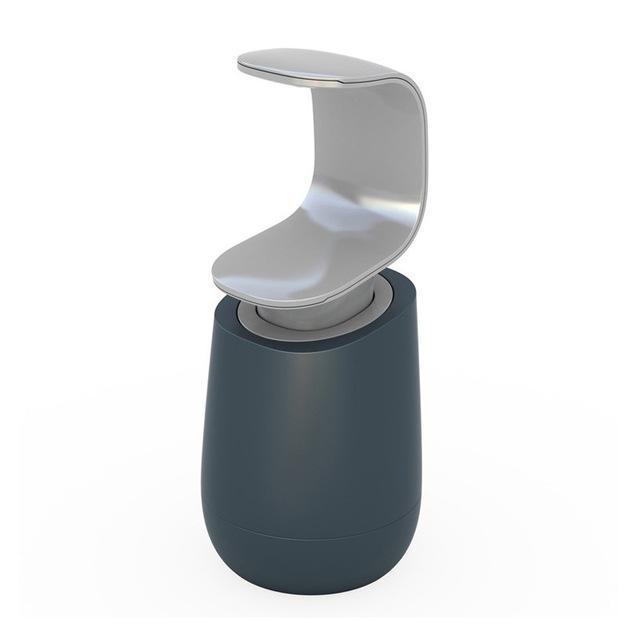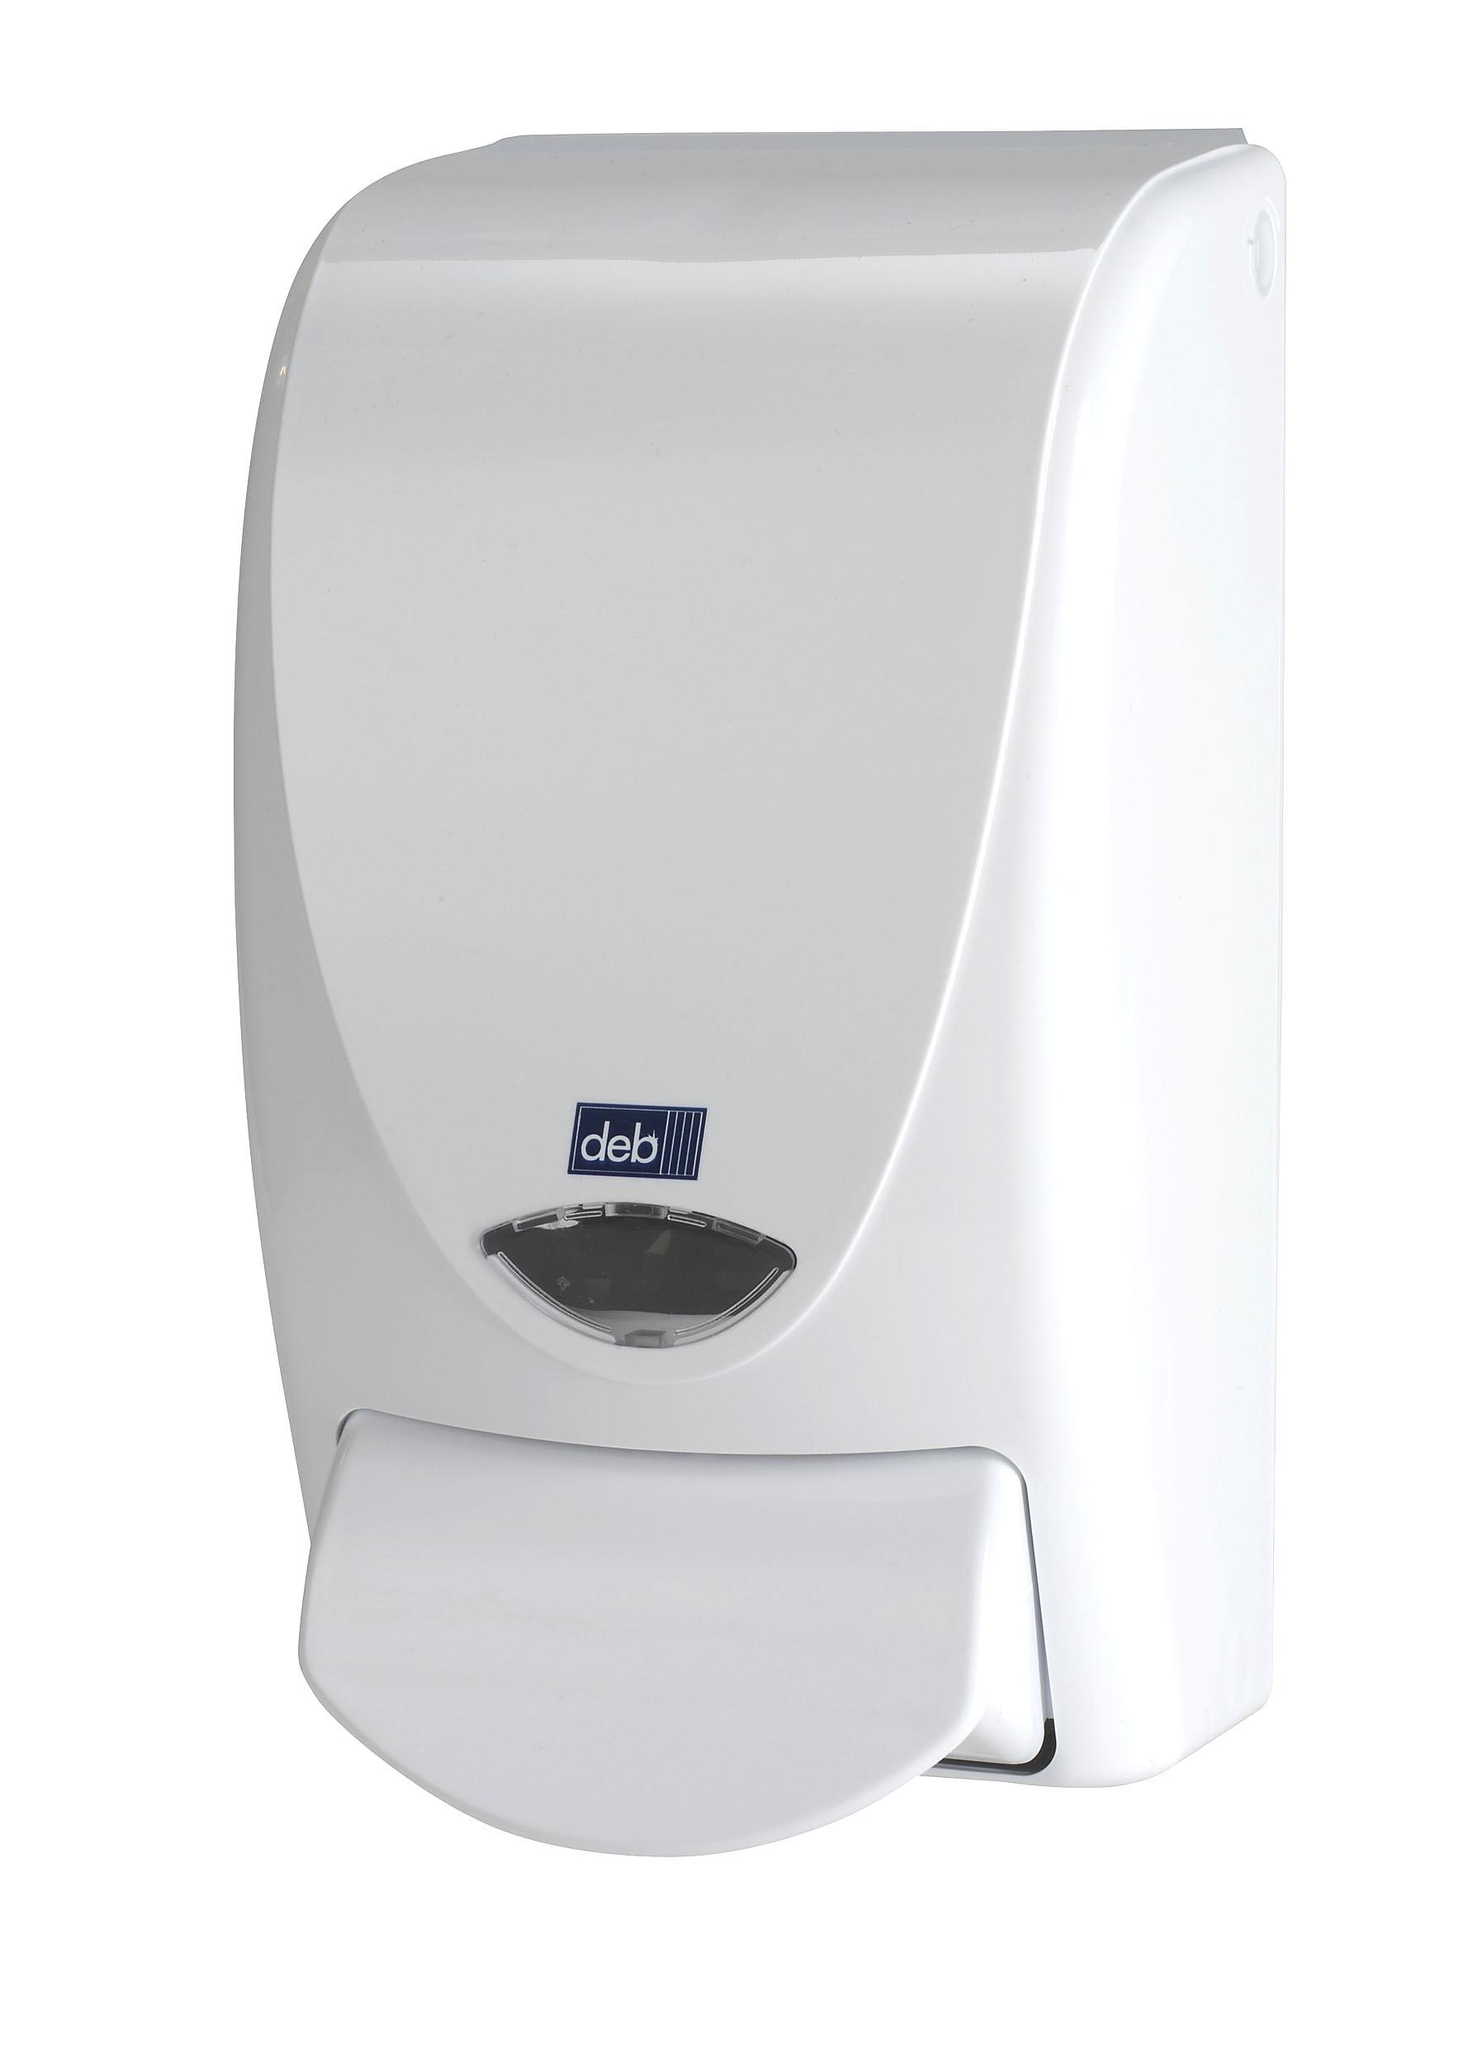The first image is the image on the left, the second image is the image on the right. For the images displayed, is the sentence "The left and right image contains the same number of wall hanging soap dispensers." factually correct? Answer yes or no. No. 